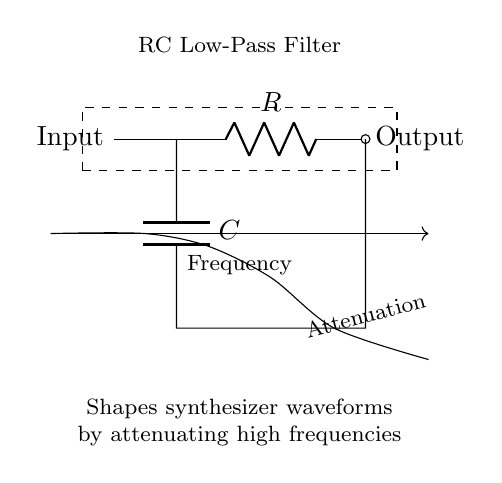What type of filter is represented by this circuit? The circuit is labeled as an RC Low-Pass Filter, indicated by the notation inside the dashed rectangle. This means it allows low frequencies to pass while attenuating higher frequencies.
Answer: RC Low-Pass Filter What are the two main components in this circuit? The circuit includes a resistor and a capacitor, designated as R and C in the diagram. These are the essential components that define the behavior of the low-pass filter.
Answer: Resistor, Capacitor What is the output of this circuit referred to as? The output is denoted in the diagram as "Output," which represents the signal after being processed by the RC filter. This indicates the filtered waveform coming out of the circuit.
Answer: Output What does the dashed rectangle signify in the diagram? The dashed rectangle encompasses the components and is labeled, indicating that everything inside is working as a single unit, specifically as an RC low-pass filter in this case.
Answer: Functionality Which frequencies does this filter attenuate? The description in the diagram states that it attenuates high frequencies, meaning those above a certain cutoff frequency will be reduced in amplitude at the output.
Answer: High frequencies How does the shape of the graph indicate the filter’s performance? The graph shows smooth attenuation as frequency increases, which confirms that lower frequencies are preserved while higher ones are increasingly weakened, demonstrating the filter's frequency response's effectiveness.
Answer: Smooth attenuation 